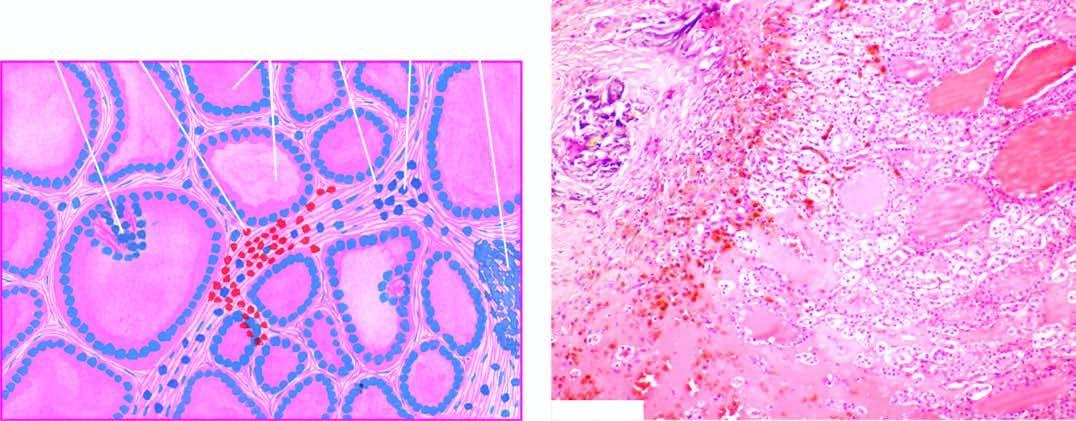re the predominant histologic features: nodularity, extensive scarring with foci of calcification, areas of haemorrhages and variable-sized follicles lined by flat to high epithelium and containing abundant colloid?
Answer the question using a single word or phrase. Yes 